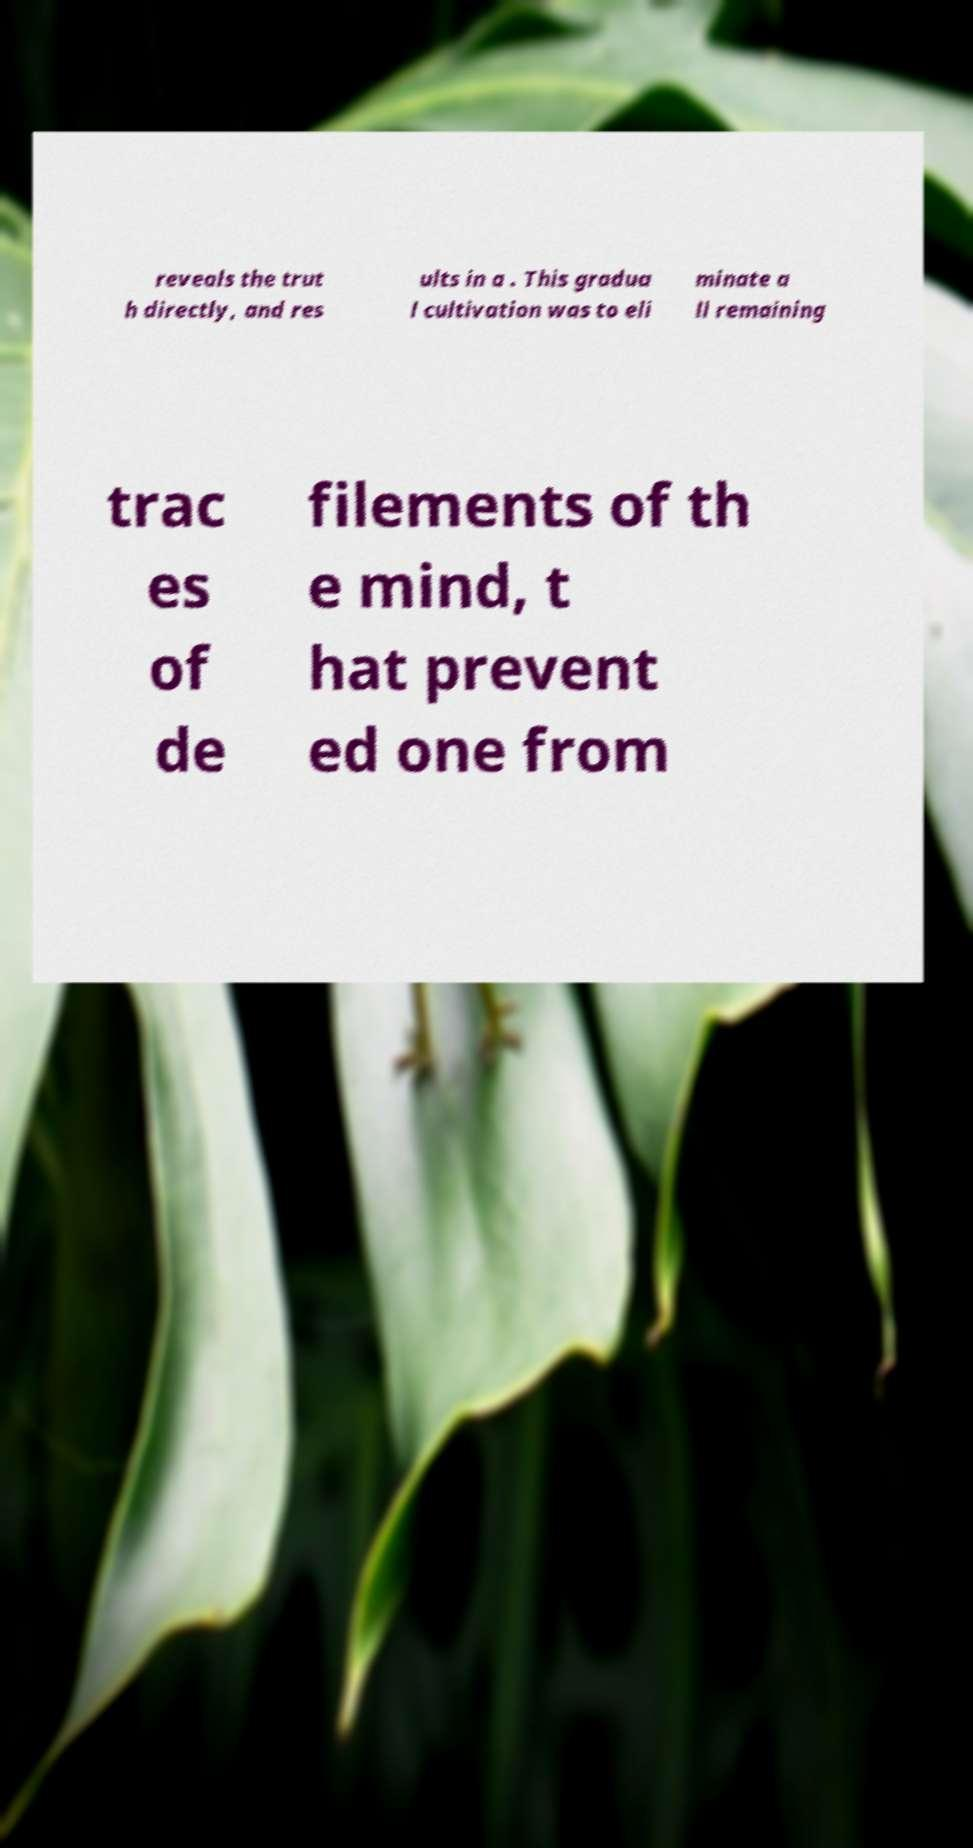Please read and relay the text visible in this image. What does it say? reveals the trut h directly, and res ults in a . This gradua l cultivation was to eli minate a ll remaining trac es of de filements of th e mind, t hat prevent ed one from 